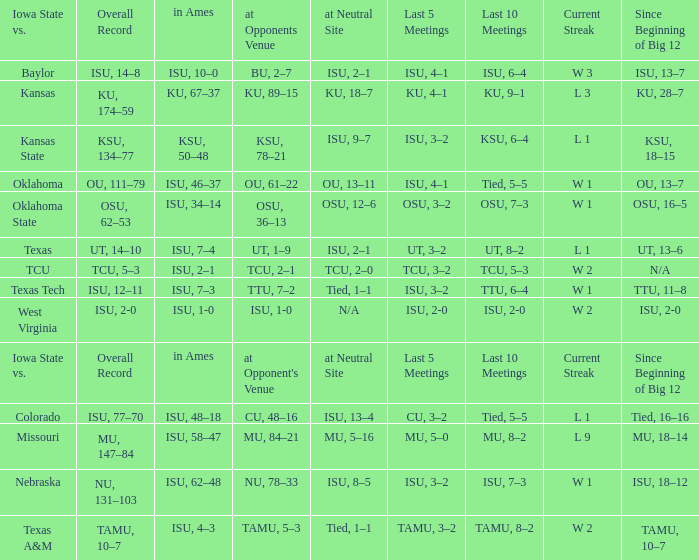When the value of "since the inception of big 12" is equivalent to its category, what are the in ames values? In ames. 